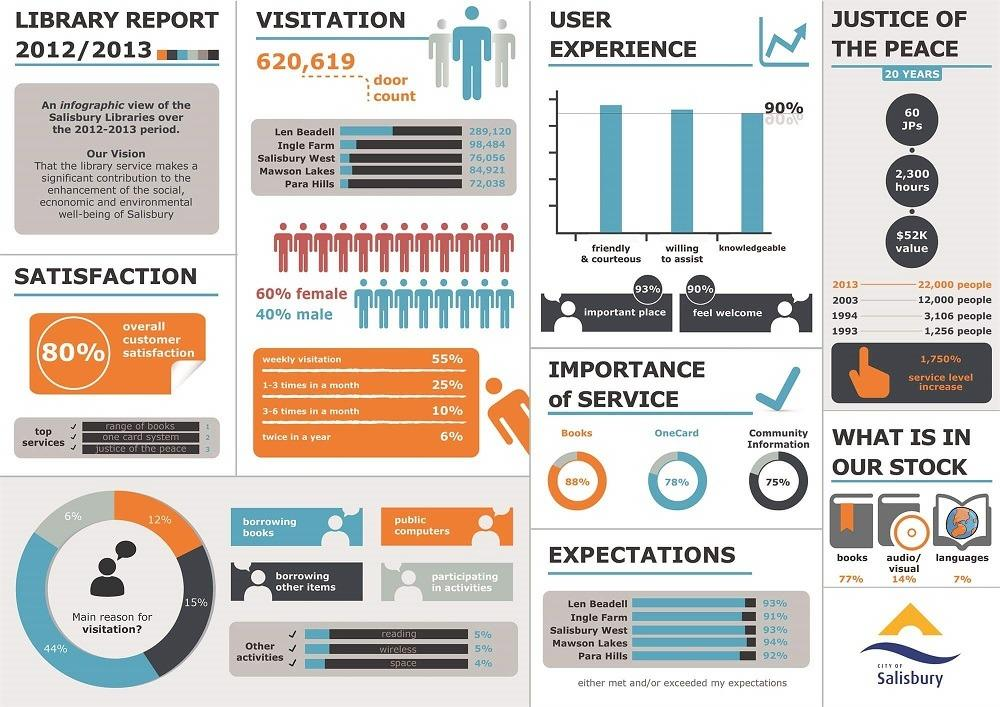List a handful of essential elements in this visual. The primary purpose of visitation-borrowing other items is to borrow books. 20% of customers are not satisfied. Eighty-four percent of the books and languages in stock are currently available. 